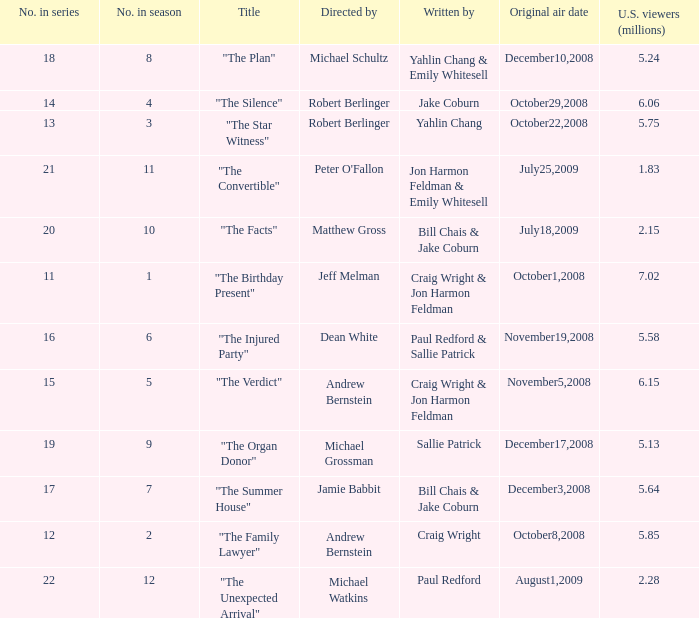83 million u.s. viewers? Jon Harmon Feldman & Emily Whitesell. 